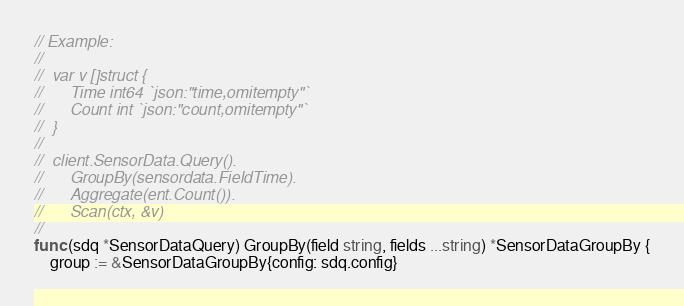Convert code to text. <code><loc_0><loc_0><loc_500><loc_500><_Go_>// Example:
//
//	var v []struct {
//		Time int64 `json:"time,omitempty"`
//		Count int `json:"count,omitempty"`
//	}
//
//	client.SensorData.Query().
//		GroupBy(sensordata.FieldTime).
//		Aggregate(ent.Count()).
//		Scan(ctx, &v)
//
func (sdq *SensorDataQuery) GroupBy(field string, fields ...string) *SensorDataGroupBy {
	group := &SensorDataGroupBy{config: sdq.config}</code> 